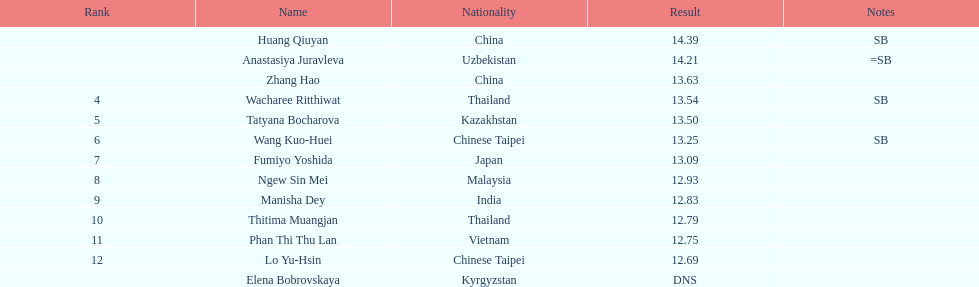How extensive was manisha dey's jump? 12.83. 